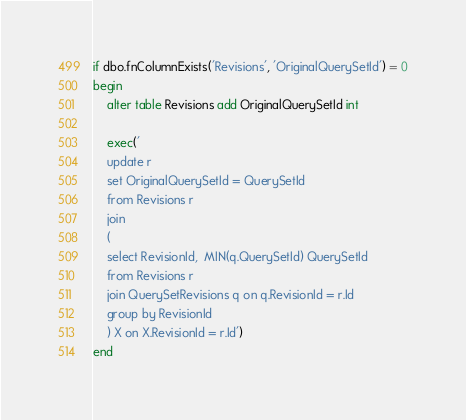Convert code to text. <code><loc_0><loc_0><loc_500><loc_500><_SQL_>if dbo.fnColumnExists('Revisions', 'OriginalQuerySetId') = 0
begin
	alter table Revisions add OriginalQuerySetId int
	
	exec('
	update r 
	set OriginalQuerySetId = QuerySetId
	from Revisions r 
	join 
	(
	select RevisionId,  MIN(q.QuerySetId) QuerySetId
	from Revisions r
	join QuerySetRevisions q on q.RevisionId = r.Id
	group by RevisionId
	) X on X.RevisionId = r.Id')
end</code> 